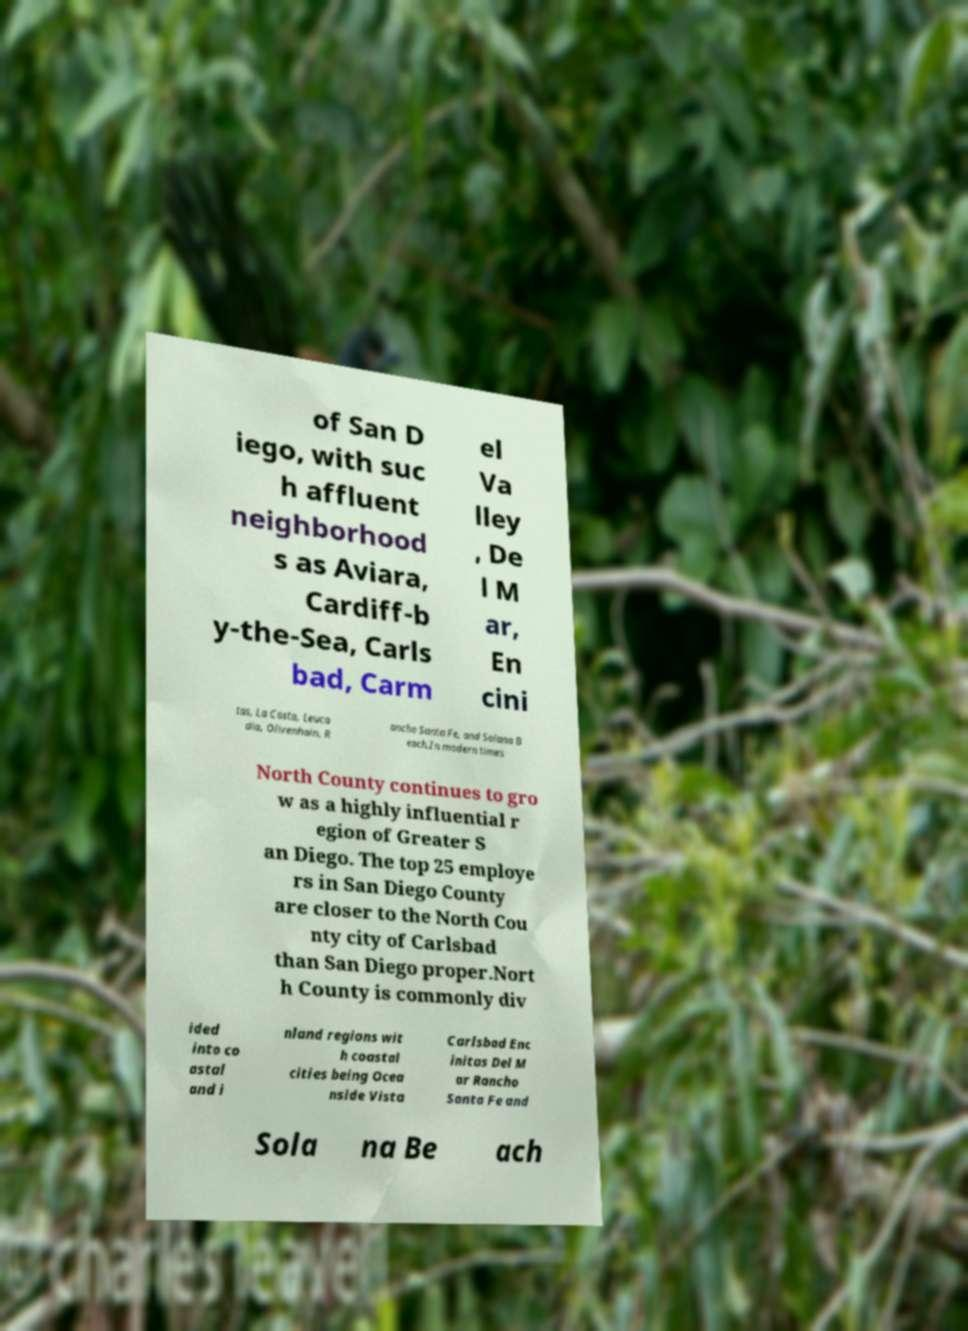Can you read and provide the text displayed in the image?This photo seems to have some interesting text. Can you extract and type it out for me? of San D iego, with suc h affluent neighborhood s as Aviara, Cardiff-b y-the-Sea, Carls bad, Carm el Va lley , De l M ar, En cini tas, La Costa, Leuca dia, Olivenhain, R ancho Santa Fe, and Solana B each.In modern times North County continues to gro w as a highly influential r egion of Greater S an Diego. The top 25 employe rs in San Diego County are closer to the North Cou nty city of Carlsbad than San Diego proper.Nort h County is commonly div ided into co astal and i nland regions wit h coastal cities being Ocea nside Vista Carlsbad Enc initas Del M ar Rancho Santa Fe and Sola na Be ach 